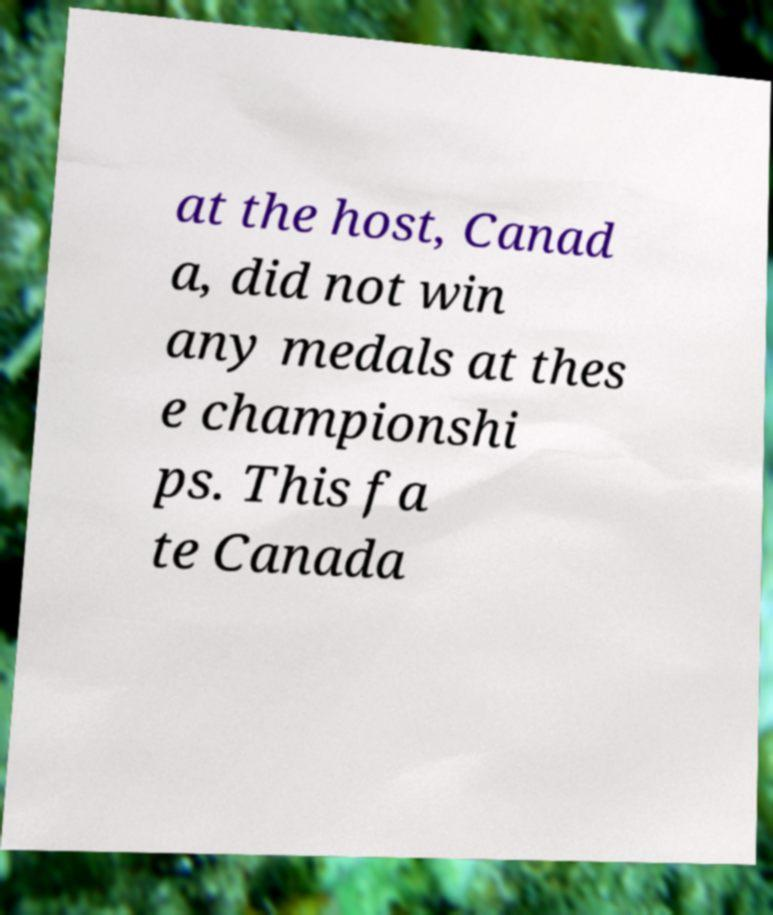For documentation purposes, I need the text within this image transcribed. Could you provide that? at the host, Canad a, did not win any medals at thes e championshi ps. This fa te Canada 